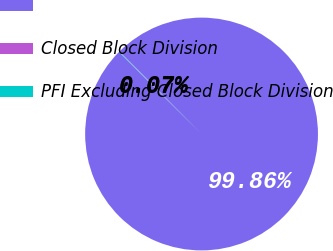Convert chart to OTSL. <chart><loc_0><loc_0><loc_500><loc_500><pie_chart><ecel><fcel>Closed Block Division<fcel>PFI Excluding Closed Block Division<nl><fcel>99.86%<fcel>0.07%<fcel>0.07%<nl></chart> 